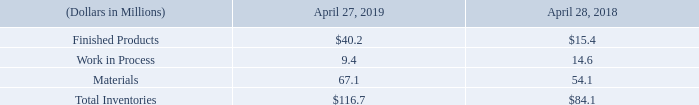Inventories.
Inventories are stated at the lower-of-cost or net realizable value. Cost is determined using the first-in, first-out method. Finished products and work-in-process inventories include direct material costs and direct and indirect manufacturing costs. The Company records reserves for inventory that may be obsolete or in excess of current and future market demand. A summary of inventories is shown below:
Which method is used to calculate cost? First-in, first-out method. Which costs are included in Finished products and work-in-progress? Direct material costs and direct and indirect manufacturing costs. What was the value of finished products in 2019 and 2018 respectively?
Answer scale should be: million. $40.2, $15.4. What was the change in the value of finished products from 2018 to 2019?
Answer scale should be: million. 40.2 - 15.4
Answer: 24.8. What is the average work in progress value for 2018 and 2019?
Answer scale should be: million. (9.4 + 14.6) / 2
Answer: 12. In which year was materials value less than 60 million? Locate and analyze materials in row 5
answer: 2018. 